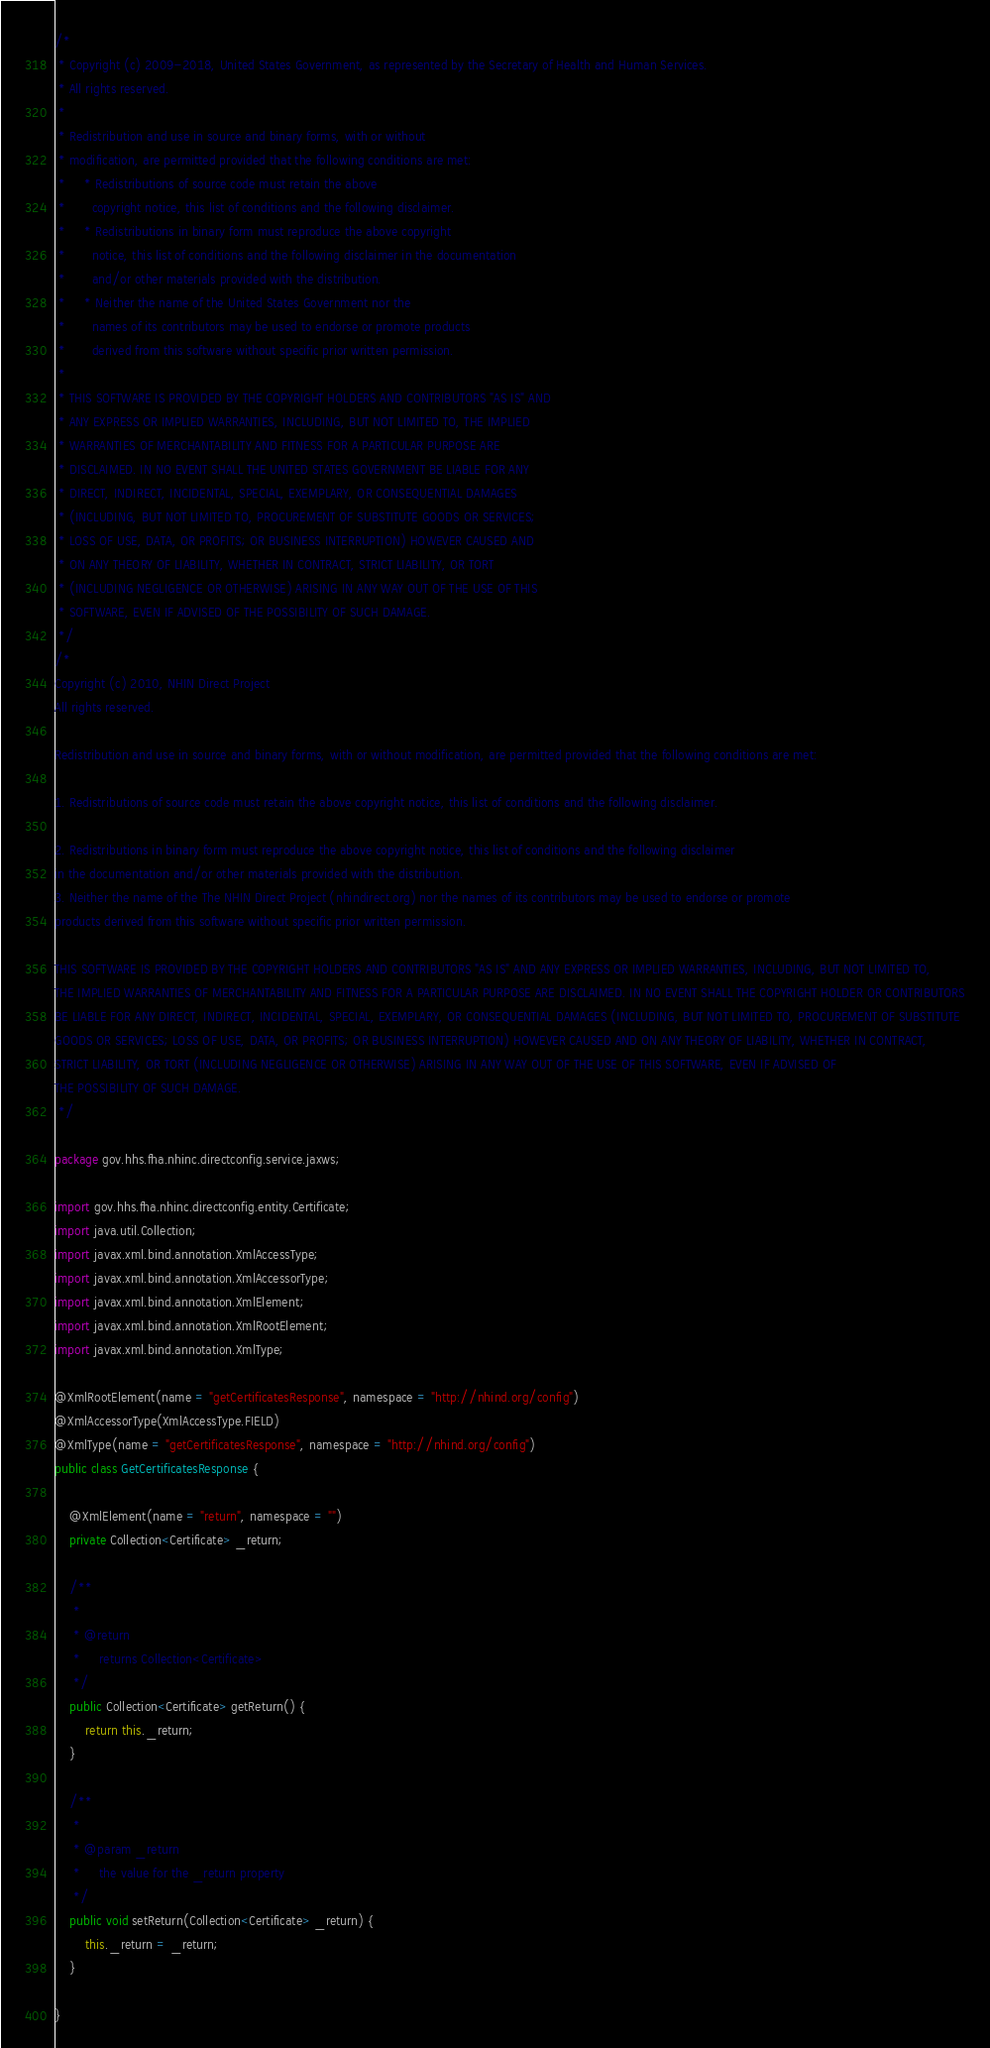Convert code to text. <code><loc_0><loc_0><loc_500><loc_500><_Java_>/*
 * Copyright (c) 2009-2018, United States Government, as represented by the Secretary of Health and Human Services.
 * All rights reserved.
 * 
 * Redistribution and use in source and binary forms, with or without
 * modification, are permitted provided that the following conditions are met:
 *     * Redistributions of source code must retain the above
 *       copyright notice, this list of conditions and the following disclaimer.
 *     * Redistributions in binary form must reproduce the above copyright
 *       notice, this list of conditions and the following disclaimer in the documentation
 *       and/or other materials provided with the distribution.
 *     * Neither the name of the United States Government nor the
 *       names of its contributors may be used to endorse or promote products
 *       derived from this software without specific prior written permission.
 * 
 * THIS SOFTWARE IS PROVIDED BY THE COPYRIGHT HOLDERS AND CONTRIBUTORS "AS IS" AND
 * ANY EXPRESS OR IMPLIED WARRANTIES, INCLUDING, BUT NOT LIMITED TO, THE IMPLIED
 * WARRANTIES OF MERCHANTABILITY AND FITNESS FOR A PARTICULAR PURPOSE ARE
 * DISCLAIMED. IN NO EVENT SHALL THE UNITED STATES GOVERNMENT BE LIABLE FOR ANY
 * DIRECT, INDIRECT, INCIDENTAL, SPECIAL, EXEMPLARY, OR CONSEQUENTIAL DAMAGES
 * (INCLUDING, BUT NOT LIMITED TO, PROCUREMENT OF SUBSTITUTE GOODS OR SERVICES;
 * LOSS OF USE, DATA, OR PROFITS; OR BUSINESS INTERRUPTION) HOWEVER CAUSED AND
 * ON ANY THEORY OF LIABILITY, WHETHER IN CONTRACT, STRICT LIABILITY, OR TORT
 * (INCLUDING NEGLIGENCE OR OTHERWISE) ARISING IN ANY WAY OUT OF THE USE OF THIS
 * SOFTWARE, EVEN IF ADVISED OF THE POSSIBILITY OF SUCH DAMAGE.
 */
/*
Copyright (c) 2010, NHIN Direct Project
All rights reserved.

Redistribution and use in source and binary forms, with or without modification, are permitted provided that the following conditions are met:

1. Redistributions of source code must retain the above copyright notice, this list of conditions and the following disclaimer.

2. Redistributions in binary form must reproduce the above copyright notice, this list of conditions and the following disclaimer
in the documentation and/or other materials provided with the distribution.
3. Neither the name of the The NHIN Direct Project (nhindirect.org) nor the names of its contributors may be used to endorse or promote
products derived from this software without specific prior written permission.

THIS SOFTWARE IS PROVIDED BY THE COPYRIGHT HOLDERS AND CONTRIBUTORS "AS IS" AND ANY EXPRESS OR IMPLIED WARRANTIES, INCLUDING, BUT NOT LIMITED TO,
THE IMPLIED WARRANTIES OF MERCHANTABILITY AND FITNESS FOR A PARTICULAR PURPOSE ARE DISCLAIMED. IN NO EVENT SHALL THE COPYRIGHT HOLDER OR CONTRIBUTORS
BE LIABLE FOR ANY DIRECT, INDIRECT, INCIDENTAL, SPECIAL, EXEMPLARY, OR CONSEQUENTIAL DAMAGES (INCLUDING, BUT NOT LIMITED TO, PROCUREMENT OF SUBSTITUTE
GOODS OR SERVICES; LOSS OF USE, DATA, OR PROFITS; OR BUSINESS INTERRUPTION) HOWEVER CAUSED AND ON ANY THEORY OF LIABILITY, WHETHER IN CONTRACT,
STRICT LIABILITY, OR TORT (INCLUDING NEGLIGENCE OR OTHERWISE) ARISING IN ANY WAY OUT OF THE USE OF THIS SOFTWARE, EVEN IF ADVISED OF
THE POSSIBILITY OF SUCH DAMAGE.
 */

package gov.hhs.fha.nhinc.directconfig.service.jaxws;

import gov.hhs.fha.nhinc.directconfig.entity.Certificate;
import java.util.Collection;
import javax.xml.bind.annotation.XmlAccessType;
import javax.xml.bind.annotation.XmlAccessorType;
import javax.xml.bind.annotation.XmlElement;
import javax.xml.bind.annotation.XmlRootElement;
import javax.xml.bind.annotation.XmlType;

@XmlRootElement(name = "getCertificatesResponse", namespace = "http://nhind.org/config")
@XmlAccessorType(XmlAccessType.FIELD)
@XmlType(name = "getCertificatesResponse", namespace = "http://nhind.org/config")
public class GetCertificatesResponse {

    @XmlElement(name = "return", namespace = "")
    private Collection<Certificate> _return;

    /**
     *
     * @return
     *     returns Collection<Certificate>
     */
    public Collection<Certificate> getReturn() {
        return this._return;
    }

    /**
     *
     * @param _return
     *     the value for the _return property
     */
    public void setReturn(Collection<Certificate> _return) {
        this._return = _return;
    }

}
</code> 